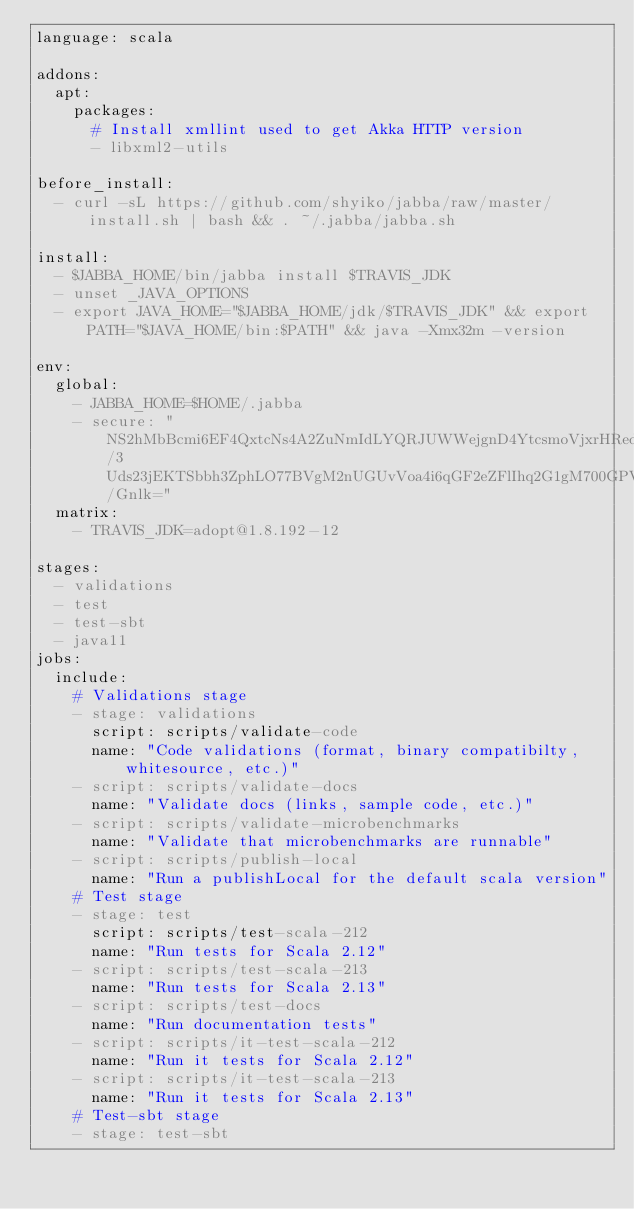<code> <loc_0><loc_0><loc_500><loc_500><_YAML_>language: scala

addons:
  apt:
    packages:
      # Install xmllint used to get Akka HTTP version
      - libxml2-utils

before_install:
  - curl -sL https://github.com/shyiko/jabba/raw/master/install.sh | bash && . ~/.jabba/jabba.sh

install:
  - $JABBA_HOME/bin/jabba install $TRAVIS_JDK
  - unset _JAVA_OPTIONS
  - export JAVA_HOME="$JABBA_HOME/jdk/$TRAVIS_JDK" && export PATH="$JAVA_HOME/bin:$PATH" && java -Xmx32m -version

env:
  global:
    - JABBA_HOME=$HOME/.jabba
    - secure: "NS2hMbBcmi6EF4QxtcNs4A2ZuNmIdLYQRJUWWejgnD4YtcsmoVjxrHRedqrnDdui4DyvaxWhg/3Uds23jEKTSbbh3ZphLO77BVgM2nUGUvVoa4i6qGF2eZFlIhq2G1gM700GPV7X4KmyjYi2HtH8CWBTkqP3g0An63mCZw/Gnlk="
  matrix:
    - TRAVIS_JDK=adopt@1.8.192-12

stages:
  - validations
  - test
  - test-sbt
  - java11
jobs:
  include:
    # Validations stage
    - stage: validations
      script: scripts/validate-code
      name: "Code validations (format, binary compatibilty, whitesource, etc.)"
    - script: scripts/validate-docs
      name: "Validate docs (links, sample code, etc.)"
    - script: scripts/validate-microbenchmarks
      name: "Validate that microbenchmarks are runnable"
    - script: scripts/publish-local
      name: "Run a publishLocal for the default scala version"
    # Test stage
    - stage: test
      script: scripts/test-scala-212
      name: "Run tests for Scala 2.12"
    - script: scripts/test-scala-213
      name: "Run tests for Scala 2.13"
    - script: scripts/test-docs
      name: "Run documentation tests"
    - script: scripts/it-test-scala-212
      name: "Run it tests for Scala 2.12"
    - script: scripts/it-test-scala-213
      name: "Run it tests for Scala 2.13"
    # Test-sbt stage
    - stage: test-sbt</code> 